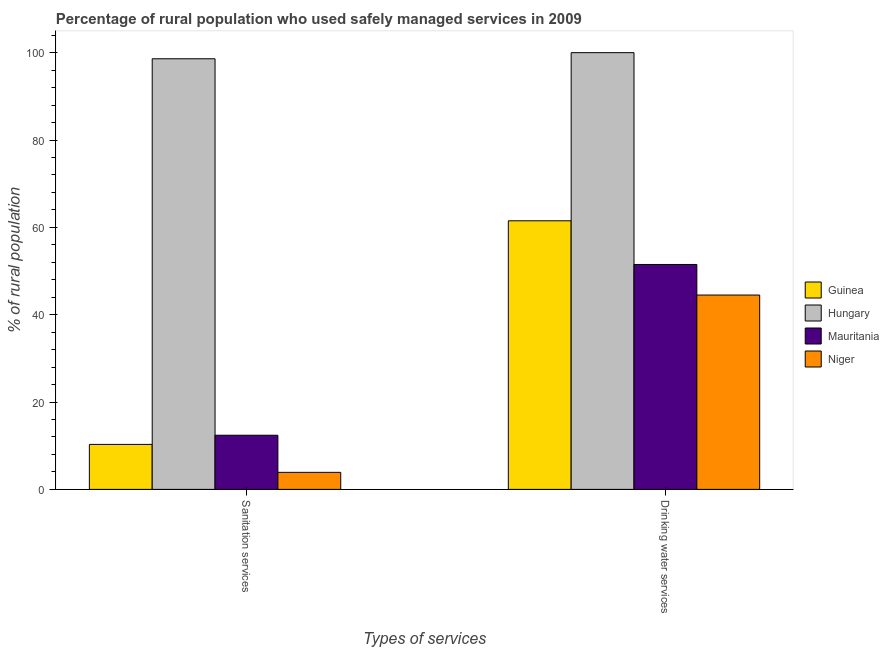How many different coloured bars are there?
Keep it short and to the point. 4. Are the number of bars on each tick of the X-axis equal?
Ensure brevity in your answer.  Yes. How many bars are there on the 2nd tick from the left?
Provide a short and direct response. 4. What is the label of the 1st group of bars from the left?
Your answer should be very brief. Sanitation services. What is the percentage of rural population who used drinking water services in Guinea?
Provide a succinct answer. 61.5. Across all countries, what is the minimum percentage of rural population who used drinking water services?
Your answer should be compact. 44.5. In which country was the percentage of rural population who used sanitation services maximum?
Ensure brevity in your answer.  Hungary. In which country was the percentage of rural population who used drinking water services minimum?
Provide a short and direct response. Niger. What is the total percentage of rural population who used drinking water services in the graph?
Provide a succinct answer. 257.5. What is the difference between the percentage of rural population who used sanitation services in Guinea and that in Hungary?
Keep it short and to the point. -88.3. What is the difference between the percentage of rural population who used sanitation services in Guinea and the percentage of rural population who used drinking water services in Hungary?
Ensure brevity in your answer.  -89.7. What is the average percentage of rural population who used drinking water services per country?
Offer a very short reply. 64.38. What is the difference between the percentage of rural population who used sanitation services and percentage of rural population who used drinking water services in Mauritania?
Keep it short and to the point. -39.1. What is the ratio of the percentage of rural population who used drinking water services in Mauritania to that in Guinea?
Offer a very short reply. 0.84. Is the percentage of rural population who used drinking water services in Guinea less than that in Mauritania?
Your answer should be very brief. No. In how many countries, is the percentage of rural population who used drinking water services greater than the average percentage of rural population who used drinking water services taken over all countries?
Your answer should be compact. 1. What does the 1st bar from the left in Drinking water services represents?
Offer a very short reply. Guinea. What does the 4th bar from the right in Sanitation services represents?
Provide a short and direct response. Guinea. Does the graph contain any zero values?
Keep it short and to the point. No. Where does the legend appear in the graph?
Offer a very short reply. Center right. What is the title of the graph?
Your answer should be very brief. Percentage of rural population who used safely managed services in 2009. Does "Zambia" appear as one of the legend labels in the graph?
Your answer should be compact. No. What is the label or title of the X-axis?
Your answer should be very brief. Types of services. What is the label or title of the Y-axis?
Ensure brevity in your answer.  % of rural population. What is the % of rural population in Hungary in Sanitation services?
Your answer should be compact. 98.6. What is the % of rural population of Mauritania in Sanitation services?
Your answer should be very brief. 12.4. What is the % of rural population in Guinea in Drinking water services?
Provide a succinct answer. 61.5. What is the % of rural population of Mauritania in Drinking water services?
Provide a succinct answer. 51.5. What is the % of rural population in Niger in Drinking water services?
Provide a short and direct response. 44.5. Across all Types of services, what is the maximum % of rural population of Guinea?
Offer a very short reply. 61.5. Across all Types of services, what is the maximum % of rural population in Mauritania?
Your answer should be very brief. 51.5. Across all Types of services, what is the maximum % of rural population of Niger?
Provide a succinct answer. 44.5. Across all Types of services, what is the minimum % of rural population in Guinea?
Ensure brevity in your answer.  10.3. Across all Types of services, what is the minimum % of rural population in Hungary?
Give a very brief answer. 98.6. What is the total % of rural population of Guinea in the graph?
Provide a succinct answer. 71.8. What is the total % of rural population in Hungary in the graph?
Make the answer very short. 198.6. What is the total % of rural population of Mauritania in the graph?
Your response must be concise. 63.9. What is the total % of rural population in Niger in the graph?
Make the answer very short. 48.4. What is the difference between the % of rural population of Guinea in Sanitation services and that in Drinking water services?
Your response must be concise. -51.2. What is the difference between the % of rural population in Hungary in Sanitation services and that in Drinking water services?
Your answer should be compact. -1.4. What is the difference between the % of rural population of Mauritania in Sanitation services and that in Drinking water services?
Your answer should be compact. -39.1. What is the difference between the % of rural population in Niger in Sanitation services and that in Drinking water services?
Your answer should be very brief. -40.6. What is the difference between the % of rural population in Guinea in Sanitation services and the % of rural population in Hungary in Drinking water services?
Ensure brevity in your answer.  -89.7. What is the difference between the % of rural population in Guinea in Sanitation services and the % of rural population in Mauritania in Drinking water services?
Provide a succinct answer. -41.2. What is the difference between the % of rural population in Guinea in Sanitation services and the % of rural population in Niger in Drinking water services?
Keep it short and to the point. -34.2. What is the difference between the % of rural population in Hungary in Sanitation services and the % of rural population in Mauritania in Drinking water services?
Your answer should be very brief. 47.1. What is the difference between the % of rural population of Hungary in Sanitation services and the % of rural population of Niger in Drinking water services?
Offer a terse response. 54.1. What is the difference between the % of rural population in Mauritania in Sanitation services and the % of rural population in Niger in Drinking water services?
Provide a short and direct response. -32.1. What is the average % of rural population of Guinea per Types of services?
Your answer should be compact. 35.9. What is the average % of rural population of Hungary per Types of services?
Offer a terse response. 99.3. What is the average % of rural population in Mauritania per Types of services?
Provide a succinct answer. 31.95. What is the average % of rural population of Niger per Types of services?
Ensure brevity in your answer.  24.2. What is the difference between the % of rural population in Guinea and % of rural population in Hungary in Sanitation services?
Make the answer very short. -88.3. What is the difference between the % of rural population of Guinea and % of rural population of Niger in Sanitation services?
Give a very brief answer. 6.4. What is the difference between the % of rural population in Hungary and % of rural population in Mauritania in Sanitation services?
Your response must be concise. 86.2. What is the difference between the % of rural population of Hungary and % of rural population of Niger in Sanitation services?
Ensure brevity in your answer.  94.7. What is the difference between the % of rural population in Mauritania and % of rural population in Niger in Sanitation services?
Offer a very short reply. 8.5. What is the difference between the % of rural population of Guinea and % of rural population of Hungary in Drinking water services?
Your response must be concise. -38.5. What is the difference between the % of rural population of Guinea and % of rural population of Niger in Drinking water services?
Provide a short and direct response. 17. What is the difference between the % of rural population in Hungary and % of rural population in Mauritania in Drinking water services?
Offer a terse response. 48.5. What is the difference between the % of rural population in Hungary and % of rural population in Niger in Drinking water services?
Offer a very short reply. 55.5. What is the ratio of the % of rural population in Guinea in Sanitation services to that in Drinking water services?
Your answer should be very brief. 0.17. What is the ratio of the % of rural population in Hungary in Sanitation services to that in Drinking water services?
Provide a short and direct response. 0.99. What is the ratio of the % of rural population in Mauritania in Sanitation services to that in Drinking water services?
Your answer should be compact. 0.24. What is the ratio of the % of rural population of Niger in Sanitation services to that in Drinking water services?
Ensure brevity in your answer.  0.09. What is the difference between the highest and the second highest % of rural population of Guinea?
Give a very brief answer. 51.2. What is the difference between the highest and the second highest % of rural population in Hungary?
Give a very brief answer. 1.4. What is the difference between the highest and the second highest % of rural population in Mauritania?
Provide a succinct answer. 39.1. What is the difference between the highest and the second highest % of rural population of Niger?
Ensure brevity in your answer.  40.6. What is the difference between the highest and the lowest % of rural population in Guinea?
Make the answer very short. 51.2. What is the difference between the highest and the lowest % of rural population in Mauritania?
Ensure brevity in your answer.  39.1. What is the difference between the highest and the lowest % of rural population of Niger?
Provide a short and direct response. 40.6. 